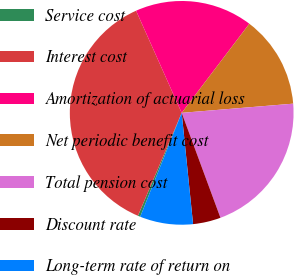Convert chart. <chart><loc_0><loc_0><loc_500><loc_500><pie_chart><fcel>Service cost<fcel>Interest cost<fcel>Amortization of actuarial loss<fcel>Net periodic benefit cost<fcel>Total pension cost<fcel>Discount rate<fcel>Long-term rate of return on<nl><fcel>0.35%<fcel>36.92%<fcel>17.02%<fcel>13.36%<fcel>20.68%<fcel>4.01%<fcel>7.67%<nl></chart> 